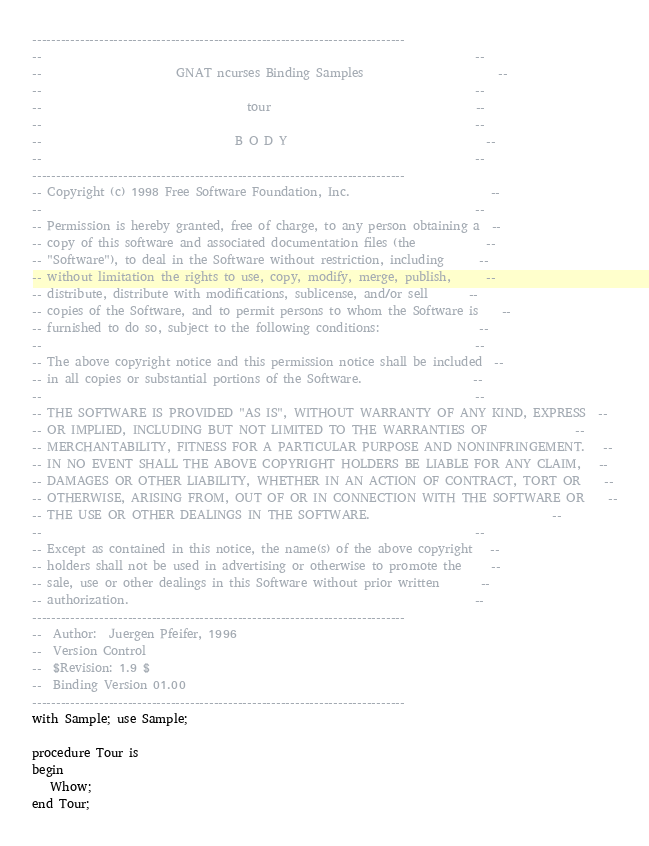<code> <loc_0><loc_0><loc_500><loc_500><_Ada_>------------------------------------------------------------------------------
--                                                                          --
--                       GNAT ncurses Binding Samples                       --
--                                                                          --
--                                   tour                                   --
--                                                                          --
--                                 B O D Y                                  --
--                                                                          --
------------------------------------------------------------------------------
-- Copyright (c) 1998 Free Software Foundation, Inc.                        --
--                                                                          --
-- Permission is hereby granted, free of charge, to any person obtaining a  --
-- copy of this software and associated documentation files (the            --
-- "Software"), to deal in the Software without restriction, including      --
-- without limitation the rights to use, copy, modify, merge, publish,      --
-- distribute, distribute with modifications, sublicense, and/or sell       --
-- copies of the Software, and to permit persons to whom the Software is    --
-- furnished to do so, subject to the following conditions:                 --
--                                                                          --
-- The above copyright notice and this permission notice shall be included  --
-- in all copies or substantial portions of the Software.                   --
--                                                                          --
-- THE SOFTWARE IS PROVIDED "AS IS", WITHOUT WARRANTY OF ANY KIND, EXPRESS  --
-- OR IMPLIED, INCLUDING BUT NOT LIMITED TO THE WARRANTIES OF               --
-- MERCHANTABILITY, FITNESS FOR A PARTICULAR PURPOSE AND NONINFRINGEMENT.   --
-- IN NO EVENT SHALL THE ABOVE COPYRIGHT HOLDERS BE LIABLE FOR ANY CLAIM,   --
-- DAMAGES OR OTHER LIABILITY, WHETHER IN AN ACTION OF CONTRACT, TORT OR    --
-- OTHERWISE, ARISING FROM, OUT OF OR IN CONNECTION WITH THE SOFTWARE OR    --
-- THE USE OR OTHER DEALINGS IN THE SOFTWARE.                               --
--                                                                          --
-- Except as contained in this notice, the name(s) of the above copyright   --
-- holders shall not be used in advertising or otherwise to promote the     --
-- sale, use or other dealings in this Software without prior written       --
-- authorization.                                                           --
------------------------------------------------------------------------------
--  Author:  Juergen Pfeifer, 1996
--  Version Control
--  $Revision: 1.9 $
--  Binding Version 01.00
------------------------------------------------------------------------------
with Sample; use Sample;

procedure Tour is
begin
   Whow;
end Tour;
</code> 